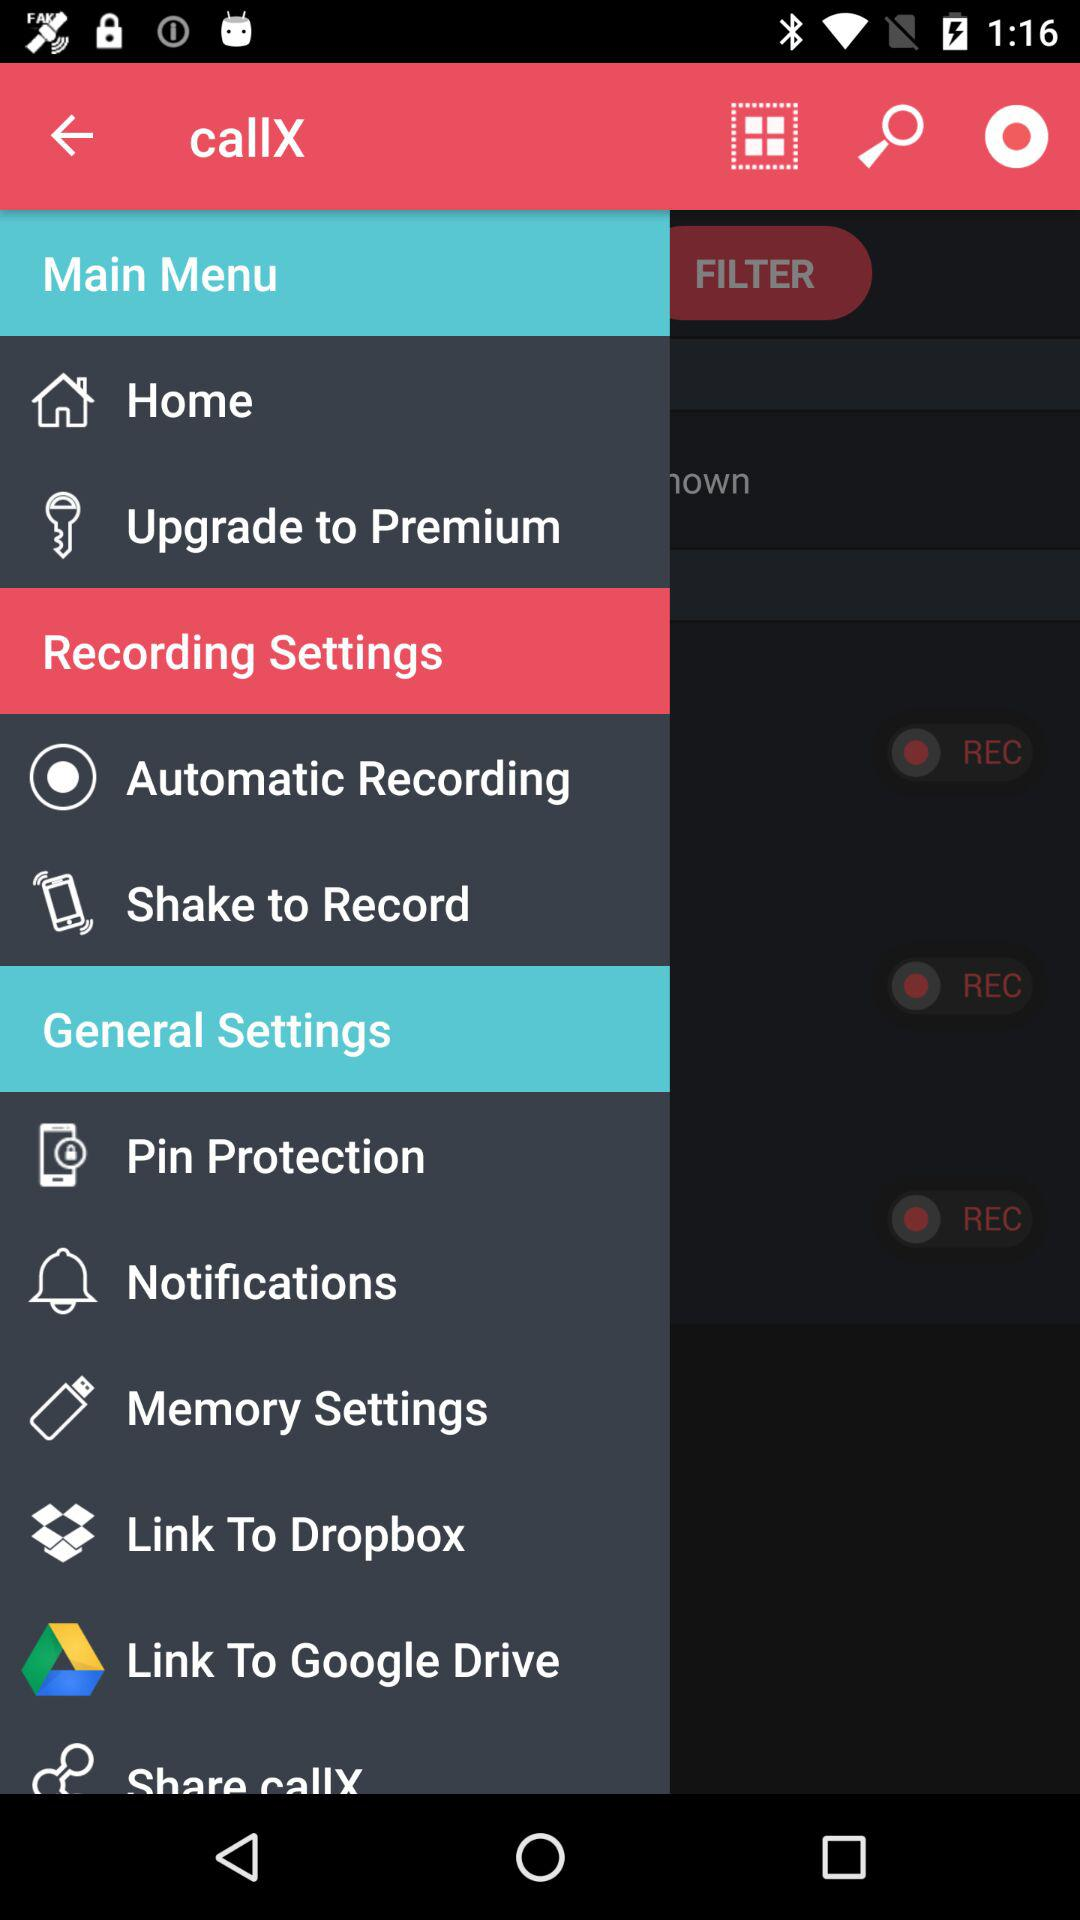How much does it cost to upgrade to a premium membership?
When the provided information is insufficient, respond with <no answer>. <no answer> 